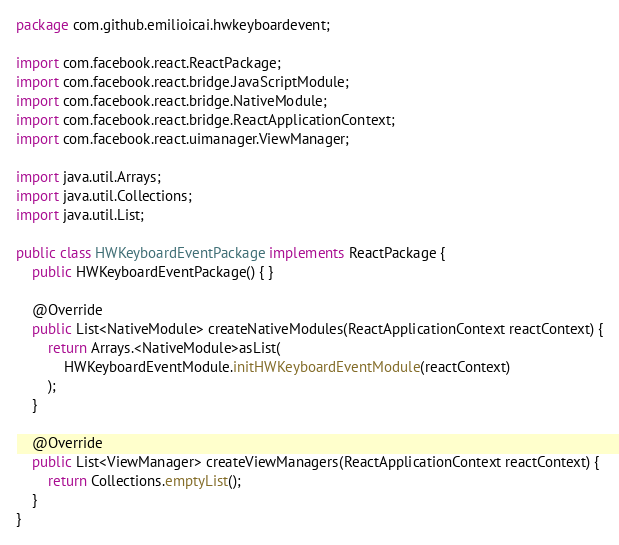Convert code to text. <code><loc_0><loc_0><loc_500><loc_500><_Java_>package com.github.emilioicai.hwkeyboardevent;

import com.facebook.react.ReactPackage;
import com.facebook.react.bridge.JavaScriptModule;
import com.facebook.react.bridge.NativeModule;
import com.facebook.react.bridge.ReactApplicationContext;
import com.facebook.react.uimanager.ViewManager;

import java.util.Arrays;
import java.util.Collections;
import java.util.List;

public class HWKeyboardEventPackage implements ReactPackage {
    public HWKeyboardEventPackage() { }

    @Override
    public List<NativeModule> createNativeModules(ReactApplicationContext reactContext) {
        return Arrays.<NativeModule>asList(
            HWKeyboardEventModule.initHWKeyboardEventModule(reactContext)
        );
    }

    @Override
    public List<ViewManager> createViewManagers(ReactApplicationContext reactContext) {
        return Collections.emptyList();
    }
}
</code> 